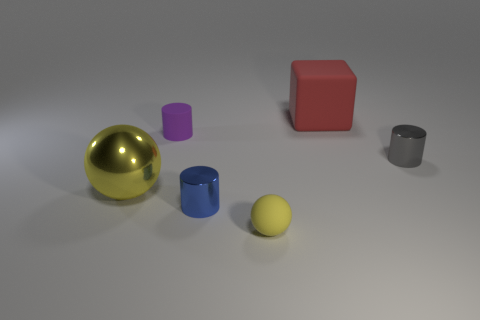Add 2 large metallic balls. How many objects exist? 8 Subtract all balls. How many objects are left? 4 Add 6 yellow things. How many yellow things exist? 8 Subtract 0 cyan spheres. How many objects are left? 6 Subtract all large metallic things. Subtract all tiny cylinders. How many objects are left? 2 Add 3 tiny metallic objects. How many tiny metallic objects are left? 5 